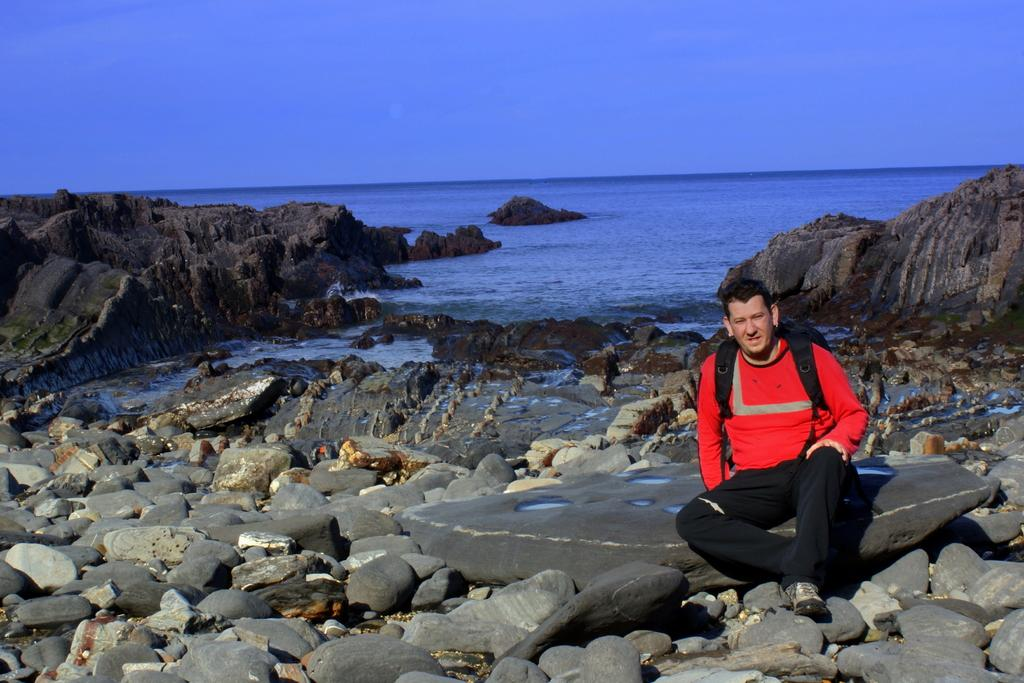What is located in the front of the image? There are stones in the front of the image. What is the main subject in the center of the image? There is a man sitting in the center of the image. What is the man wearing? The man is wearing a bag. What color is the bag? The bag is black in color. What can be seen in the background of the image? There is an ocean in the background of the image. How many rails can be seen in the image? There are no rails present in the image. What type of man is depicted in the image? The question is unclear and cannot be answered definitively based on the provided facts. The image only shows a man sitting, and there is no information about his type or characteristics. 